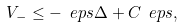<formula> <loc_0><loc_0><loc_500><loc_500>V _ { - } \leq - \ e p s \Delta + C _ { \ } e p s ,</formula> 